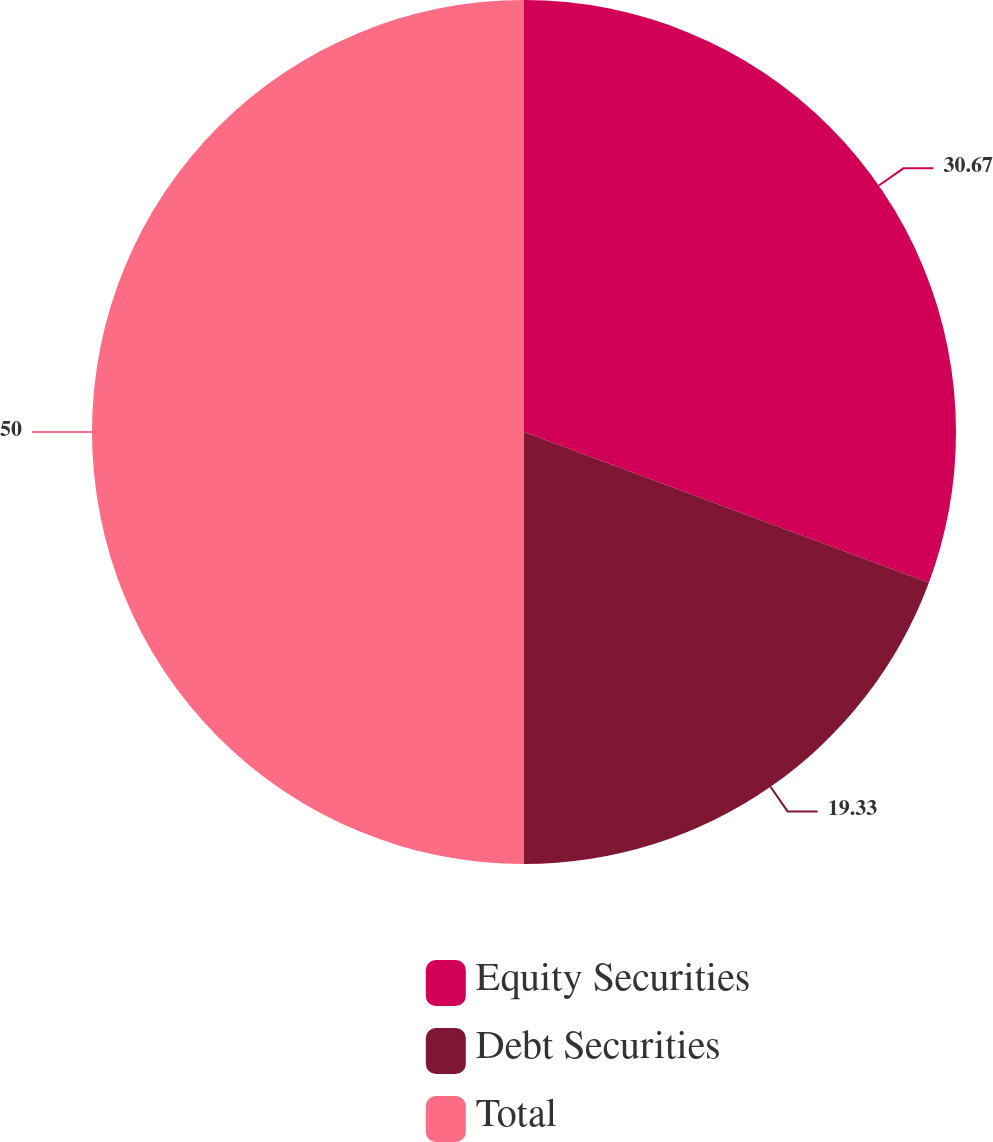Convert chart. <chart><loc_0><loc_0><loc_500><loc_500><pie_chart><fcel>Equity Securities<fcel>Debt Securities<fcel>Total<nl><fcel>30.67%<fcel>19.33%<fcel>50.0%<nl></chart> 